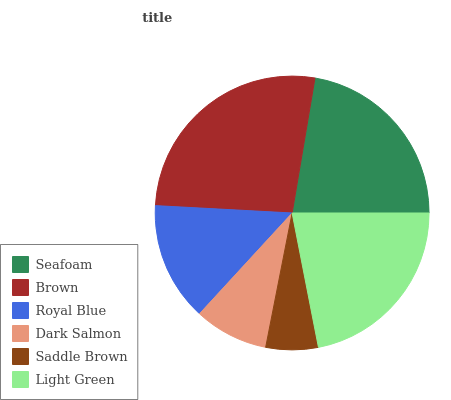Is Saddle Brown the minimum?
Answer yes or no. Yes. Is Brown the maximum?
Answer yes or no. Yes. Is Royal Blue the minimum?
Answer yes or no. No. Is Royal Blue the maximum?
Answer yes or no. No. Is Brown greater than Royal Blue?
Answer yes or no. Yes. Is Royal Blue less than Brown?
Answer yes or no. Yes. Is Royal Blue greater than Brown?
Answer yes or no. No. Is Brown less than Royal Blue?
Answer yes or no. No. Is Light Green the high median?
Answer yes or no. Yes. Is Royal Blue the low median?
Answer yes or no. Yes. Is Seafoam the high median?
Answer yes or no. No. Is Dark Salmon the low median?
Answer yes or no. No. 